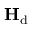Convert formula to latex. <formula><loc_0><loc_0><loc_500><loc_500>{ H } _ { d }</formula> 